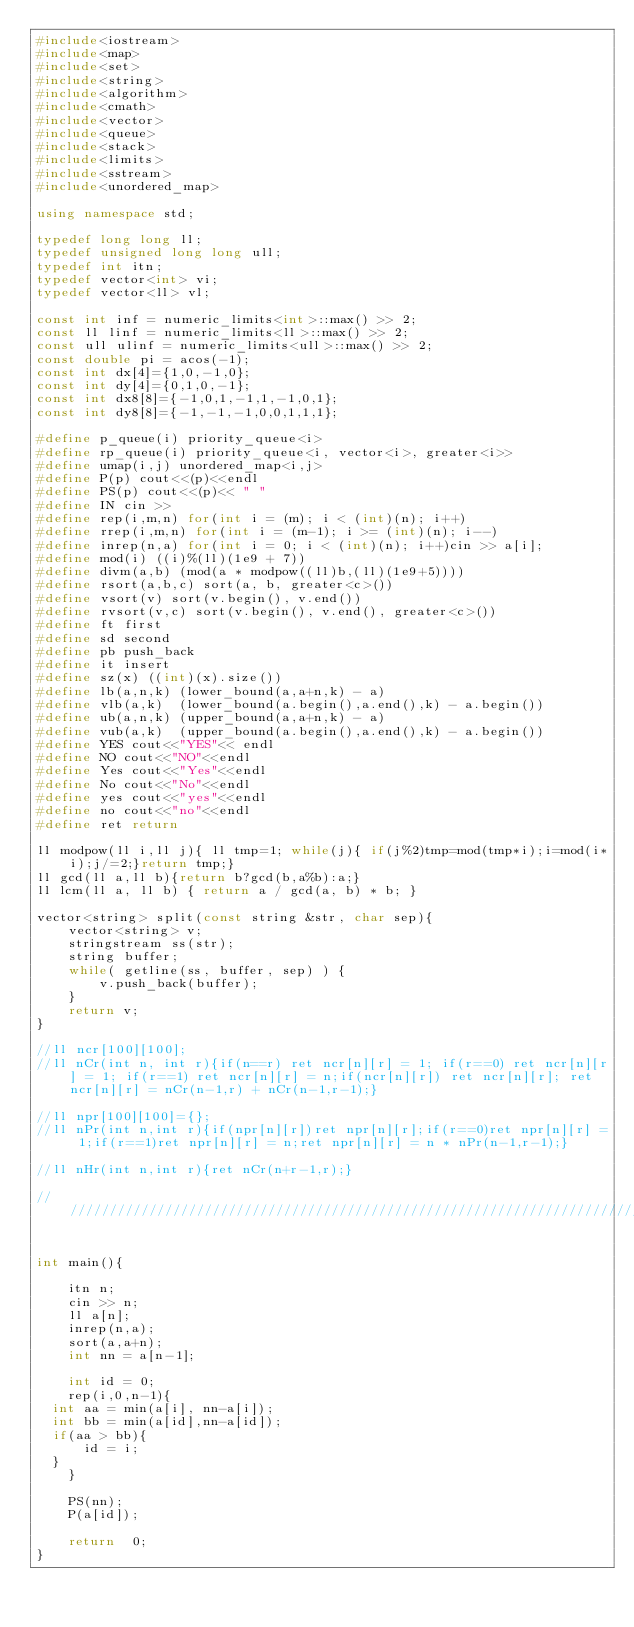<code> <loc_0><loc_0><loc_500><loc_500><_C++_>#include<iostream>
#include<map>
#include<set>
#include<string>
#include<algorithm>
#include<cmath>
#include<vector>
#include<queue>
#include<stack>
#include<limits>
#include<sstream> 
#include<unordered_map>      

using namespace std;

typedef long long ll;
typedef unsigned long long ull;
typedef int itn;
typedef vector<int> vi;
typedef vector<ll> vl;

const int inf = numeric_limits<int>::max() >> 2;
const ll linf = numeric_limits<ll>::max() >> 2;
const ull ulinf = numeric_limits<ull>::max() >> 2;
const double pi = acos(-1);
const int dx[4]={1,0,-1,0};
const int dy[4]={0,1,0,-1};
const int dx8[8]={-1,0,1,-1,1,-1,0,1};
const int dy8[8]={-1,-1,-1,0,0,1,1,1};

#define p_queue(i) priority_queue<i> 
#define rp_queue(i) priority_queue<i, vector<i>, greater<i>> 
#define umap(i,j) unordered_map<i,j>
#define P(p) cout<<(p)<<endl
#define PS(p) cout<<(p)<< " "
#define IN cin >> 
#define rep(i,m,n) for(int i = (m); i < (int)(n); i++)
#define rrep(i,m,n) for(int i = (m-1); i >= (int)(n); i--)
#define inrep(n,a) for(int i = 0; i < (int)(n); i++)cin >> a[i];
#define mod(i) ((i)%(ll)(1e9 + 7))
#define divm(a,b) (mod(a * modpow((ll)b,(ll)(1e9+5))))
#define rsort(a,b,c) sort(a, b, greater<c>())
#define vsort(v) sort(v.begin(), v.end())
#define rvsort(v,c) sort(v.begin(), v.end(), greater<c>()) 
#define ft first
#define sd second
#define pb push_back
#define it insert
#define sz(x) ((int)(x).size())
#define lb(a,n,k) (lower_bound(a,a+n,k) - a) 
#define vlb(a,k)  (lower_bound(a.begin(),a.end(),k) - a.begin())
#define ub(a,n,k) (upper_bound(a,a+n,k) - a) 
#define vub(a,k)  (upper_bound(a.begin(),a.end(),k) - a.begin())
#define YES cout<<"YES"<< endl
#define NO cout<<"NO"<<endl
#define Yes cout<<"Yes"<<endl
#define No cout<<"No"<<endl  
#define yes cout<<"yes"<<endl
#define no cout<<"no"<<endl
#define ret return

ll modpow(ll i,ll j){ ll tmp=1; while(j){ if(j%2)tmp=mod(tmp*i);i=mod(i*i);j/=2;}return tmp;}
ll gcd(ll a,ll b){return b?gcd(b,a%b):a;}
ll lcm(ll a, ll b) { return a / gcd(a, b) * b; }

vector<string> split(const string &str, char sep){
    vector<string> v;
    stringstream ss(str);
    string buffer;
    while( getline(ss, buffer, sep) ) {
        v.push_back(buffer);
    }
    return v;
}

//ll ncr[100][100];
//ll nCr(int n, int r){if(n==r) ret ncr[n][r] = 1; if(r==0) ret ncr[n][r] = 1; if(r==1) ret ncr[n][r] = n;if(ncr[n][r]) ret ncr[n][r]; ret ncr[n][r] = nCr(n-1,r) + nCr(n-1,r-1);}

//ll npr[100][100]={};
//ll nPr(int n,int r){if(npr[n][r])ret npr[n][r];if(r==0)ret npr[n][r] = 1;if(r==1)ret npr[n][r] = n;ret npr[n][r] = n * nPr(n-1,r-1);}

//ll nHr(int n,int r){ret nCr(n+r-1,r);}

///////////////////////////////////////////////////////////////////////////


int main(){
    
    itn n;
    cin >> n;
    ll a[n];
    inrep(n,a);
    sort(a,a+n);
    int nn = a[n-1];
   
    int id = 0;
    rep(i,0,n-1){
	int aa = min(a[i], nn-a[i]);
	int bb = min(a[id],nn-a[id]);
	if(aa > bb){
	    id = i;
	}
    }

    PS(nn);
    P(a[id]);
    
    return  0;
}
</code> 